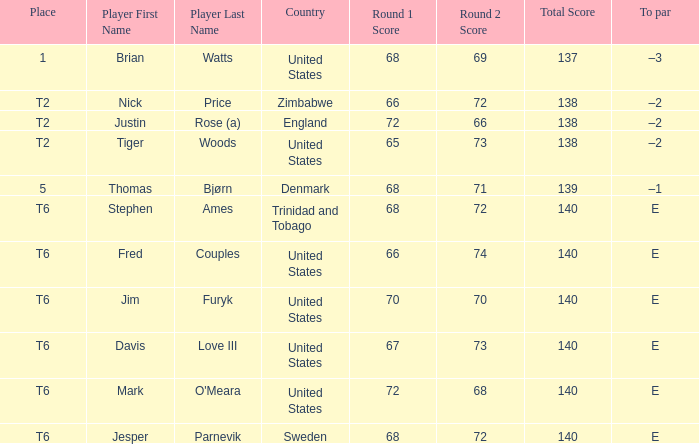What was the TO par for the player who scored 68-71=139? –1. 